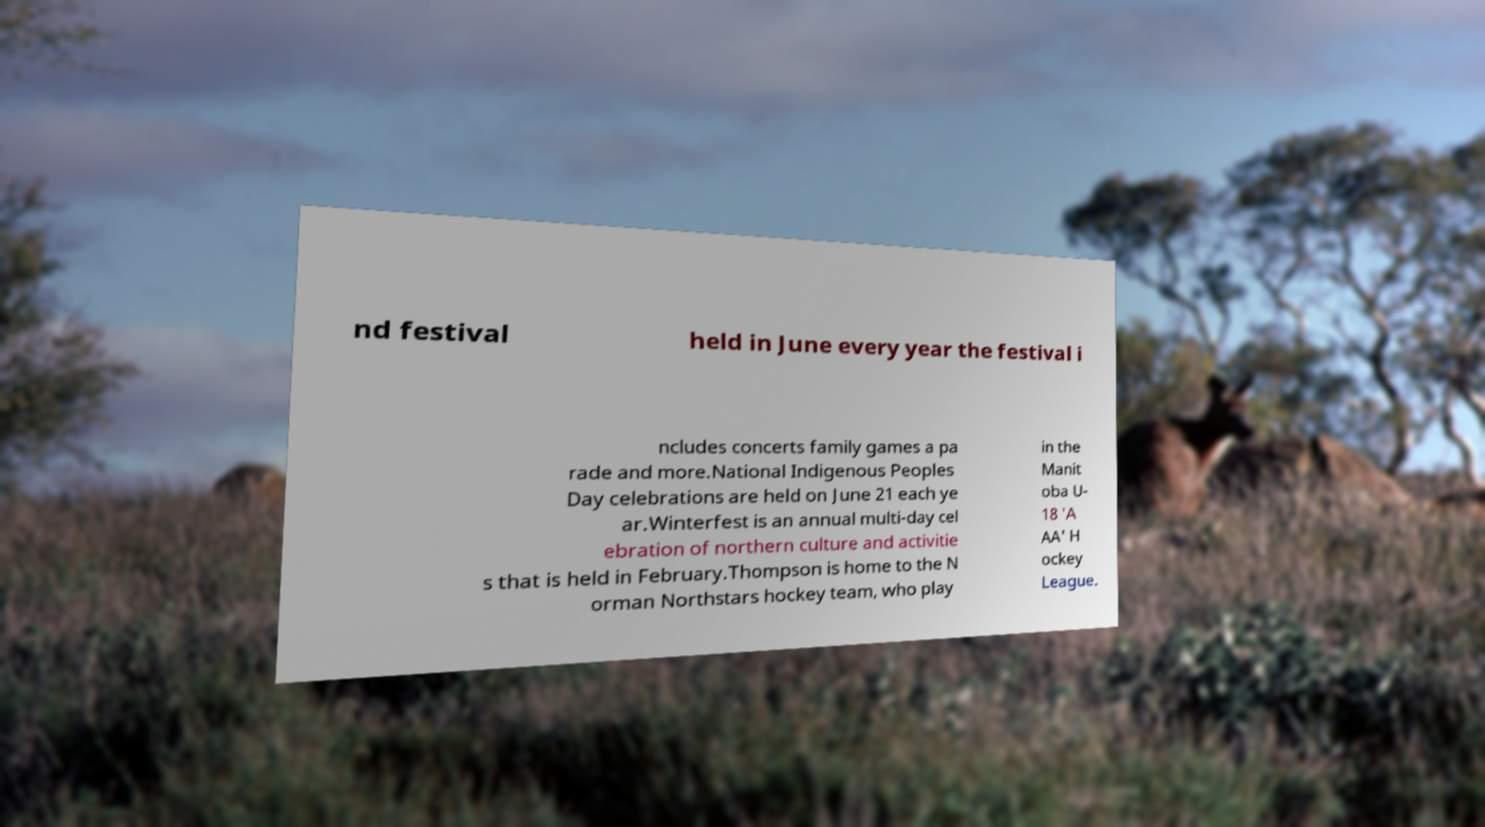What messages or text are displayed in this image? I need them in a readable, typed format. nd festival held in June every year the festival i ncludes concerts family games a pa rade and more.National Indigenous Peoples Day celebrations are held on June 21 each ye ar.Winterfest is an annual multi-day cel ebration of northern culture and activitie s that is held in February.Thompson is home to the N orman Northstars hockey team, who play in the Manit oba U- 18 'A AA' H ockey League. 